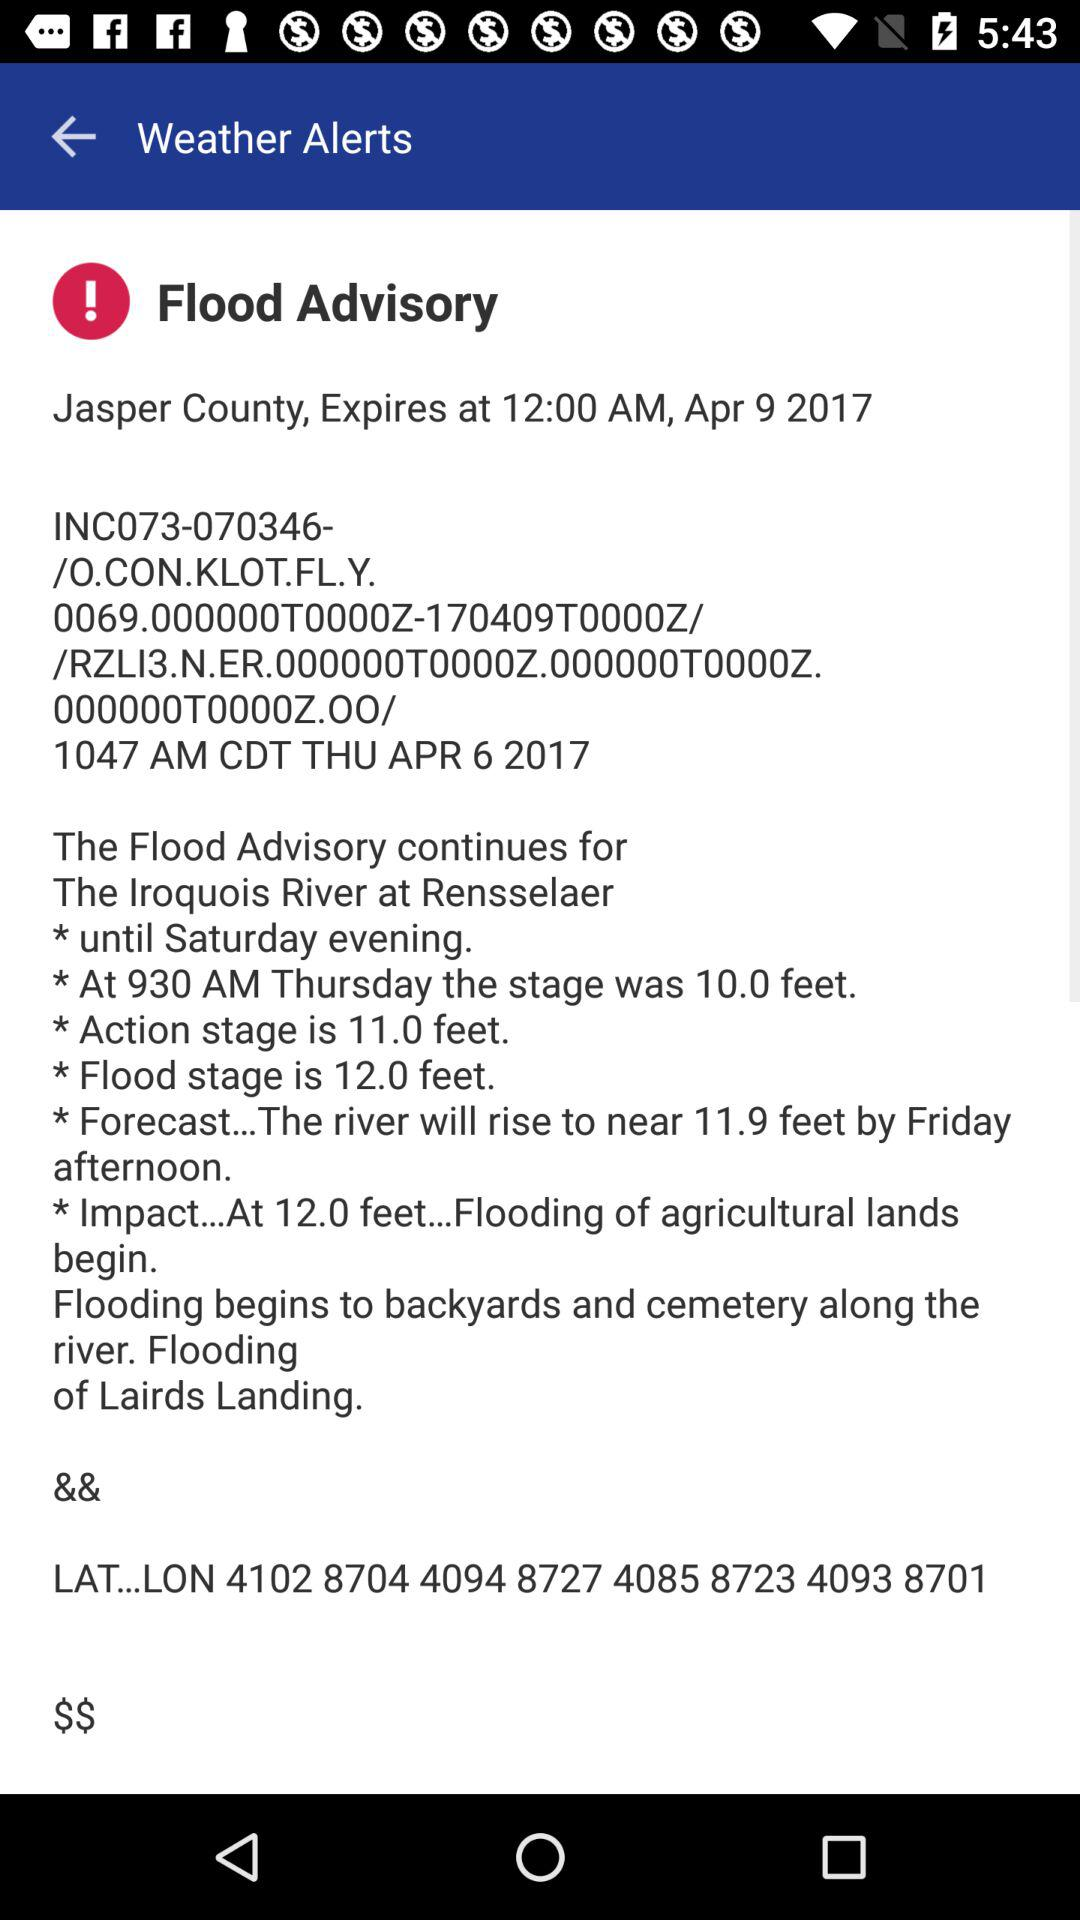What's the height of the action stage & flood stage? The height of the action stage & flood stage is 11 feet and 12 feet respectively. 